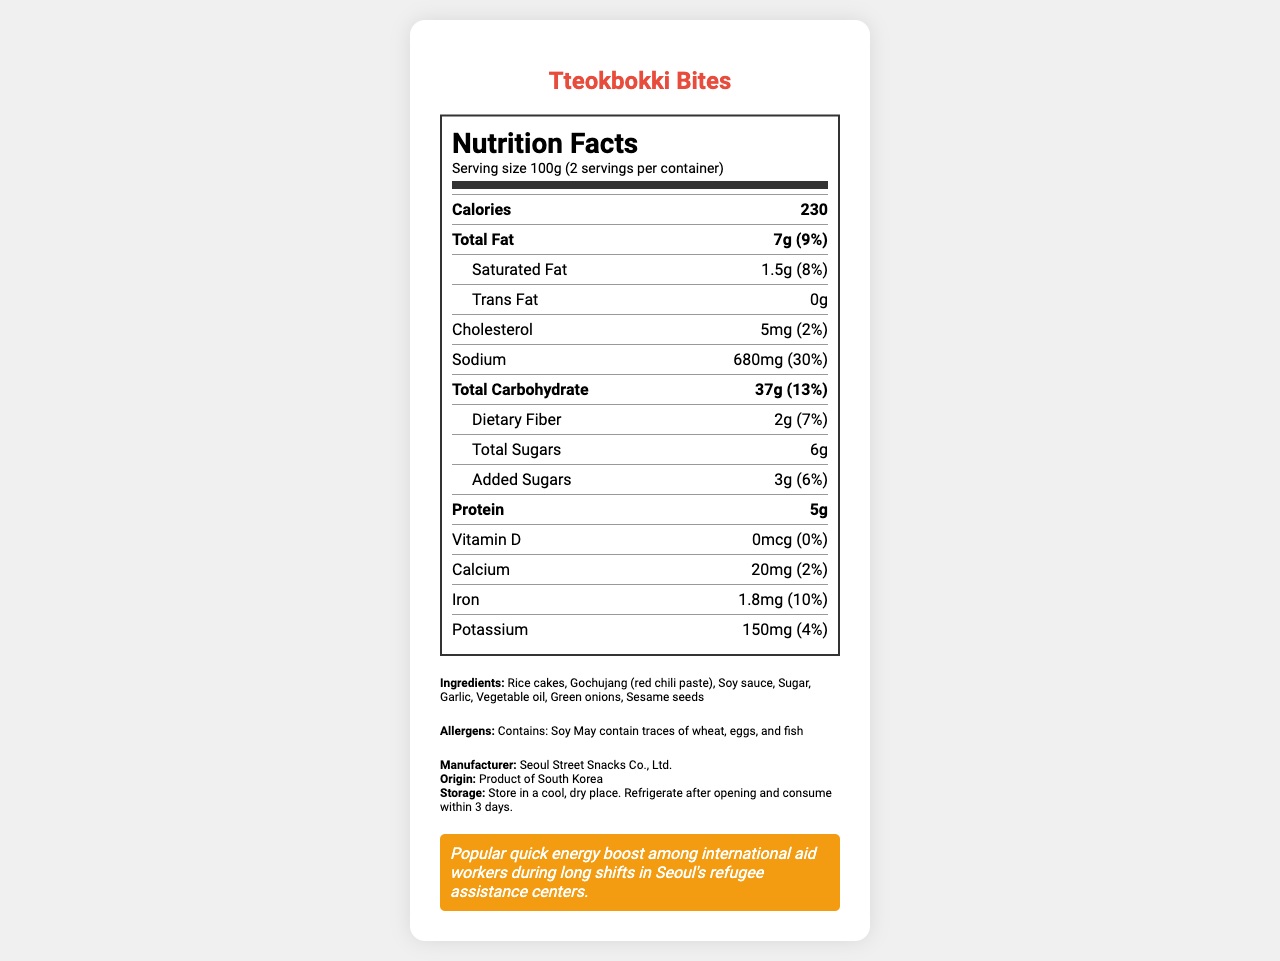what is the serving size of Tteokbokki Bites? The document states that the serving size is 100g.
Answer: 100g how many calories are in one serving of Tteokbokki Bites? Under the "Calories" section, the document indicates that there are 230 calories per serving.
Answer: 230 calories what is the percentage of daily value for sodium? The sodium content is listed as 680mg, which corresponds to 30% of the daily value.
Answer: 30% name the main ingredient in Tteokbokki Bites The first ingredient listed is "Rice cakes".
Answer: Rice cakes how much protein is in one serving? The protein content per serving is shown as 5g.
Answer: 5g which of the following nutrients has the lowest percentage of daily value? A. Vitamin D B. Iron C. Potassium D. Calcium Vitamin D has a daily value of 0%, which is the lowest among the nutrients listed.
Answer: A how many servings are there per container? A. 1 B. 2 C. 3 D. 4 The document states that there are 2 servings per container.
Answer: B is Tteokbokki Bites manufactured in South Korea? The document indicates that the product is of South Korean origin.
Answer: Yes summarize the main idea of this document. The document is a detailed nutrition facts label for the product "Tteokbokki Bites", offering essential nutritional information and ingredients, as well as special notes for aid workers who frequently consume this snack during their long shifts.
Answer: The document provides detailed nutritional information and ingredients for "Tteokbokki Bites", a Korean street food snack that is popular among international aid workers. It includes serving size, calorie count, macronutrients, vitamins, minerals, and allergens. Instructions for storage and some notes specifically for aid workers are also included. which company manufactures Tteokbokki Bites? The manufacturer is listed as "Seoul Street Snacks Co., Ltd." in the document.
Answer: Seoul Street Snacks Co., Ltd. is there any information about the expiration date of Tteokbokki Bites? The document does not provide any details about the expiration date.
Answer: Not enough information 